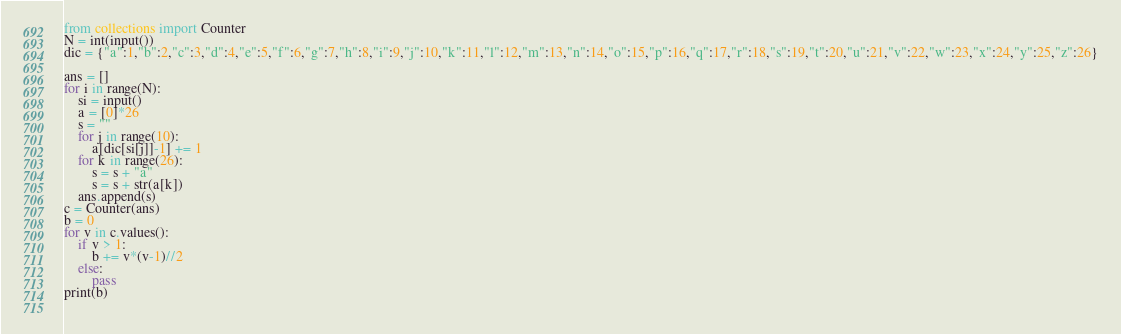Convert code to text. <code><loc_0><loc_0><loc_500><loc_500><_Python_>from collections import Counter
N = int(input())
dic = {"a":1,"b":2,"c":3,"d":4,"e":5,"f":6,"g":7,"h":8,"i":9,"j":10,"k":11,"l":12,"m":13,"n":14,"o":15,"p":16,"q":17,"r":18,"s":19,"t":20,"u":21,"v":22,"w":23,"x":24,"y":25,"z":26}

ans = []
for i in range(N):
    si = input()
    a = [0]*26
    s = ""
    for j in range(10):
        a[dic[si[j]]-1] += 1
    for k in range(26):
        s = s + "a"
        s = s + str(a[k])
    ans.append(s)
c = Counter(ans)
b = 0
for v in c.values():
    if v > 1:
        b += v*(v-1)//2
    else:
        pass
print(b)
    </code> 